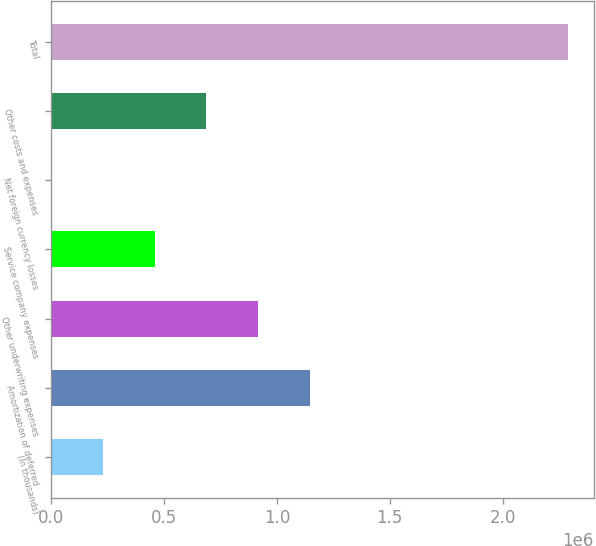<chart> <loc_0><loc_0><loc_500><loc_500><bar_chart><fcel>(In thousands)<fcel>Amortization of deferred<fcel>Other underwriting expenses<fcel>Service company expenses<fcel>Net foreign currency losses<fcel>Other costs and expenses<fcel>Total<nl><fcel>229335<fcel>1.14508e+06<fcel>916140<fcel>458270<fcel>400<fcel>687205<fcel>2.28975e+06<nl></chart> 